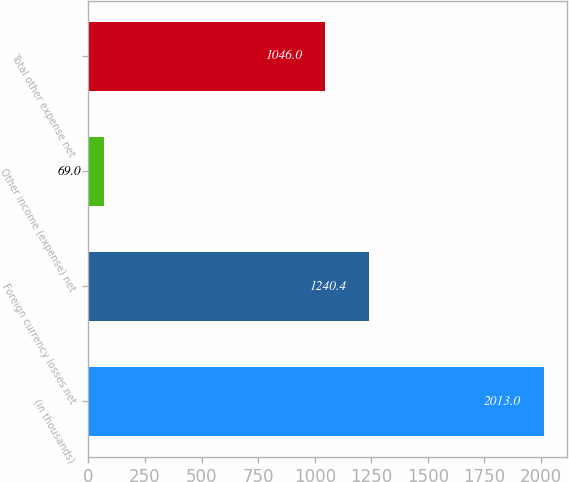Convert chart to OTSL. <chart><loc_0><loc_0><loc_500><loc_500><bar_chart><fcel>(in thousands)<fcel>Foreign currency losses net<fcel>Other income (expense) net<fcel>Total other expense net<nl><fcel>2013<fcel>1240.4<fcel>69<fcel>1046<nl></chart> 